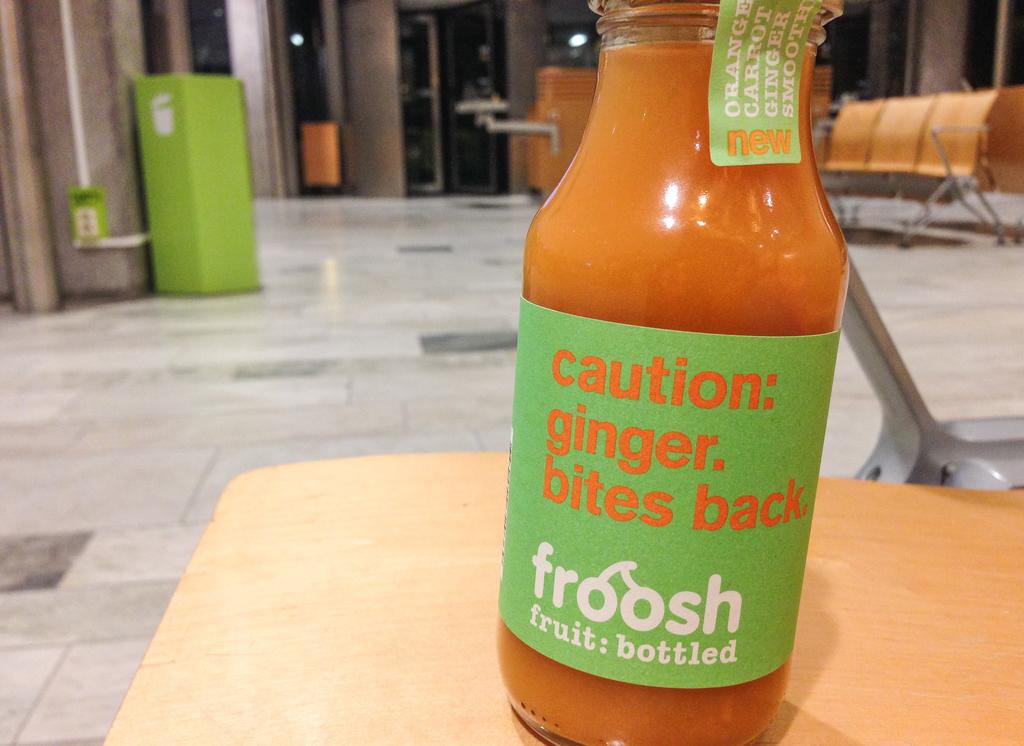What is the name of this drink?
Offer a terse response. Froosh. 